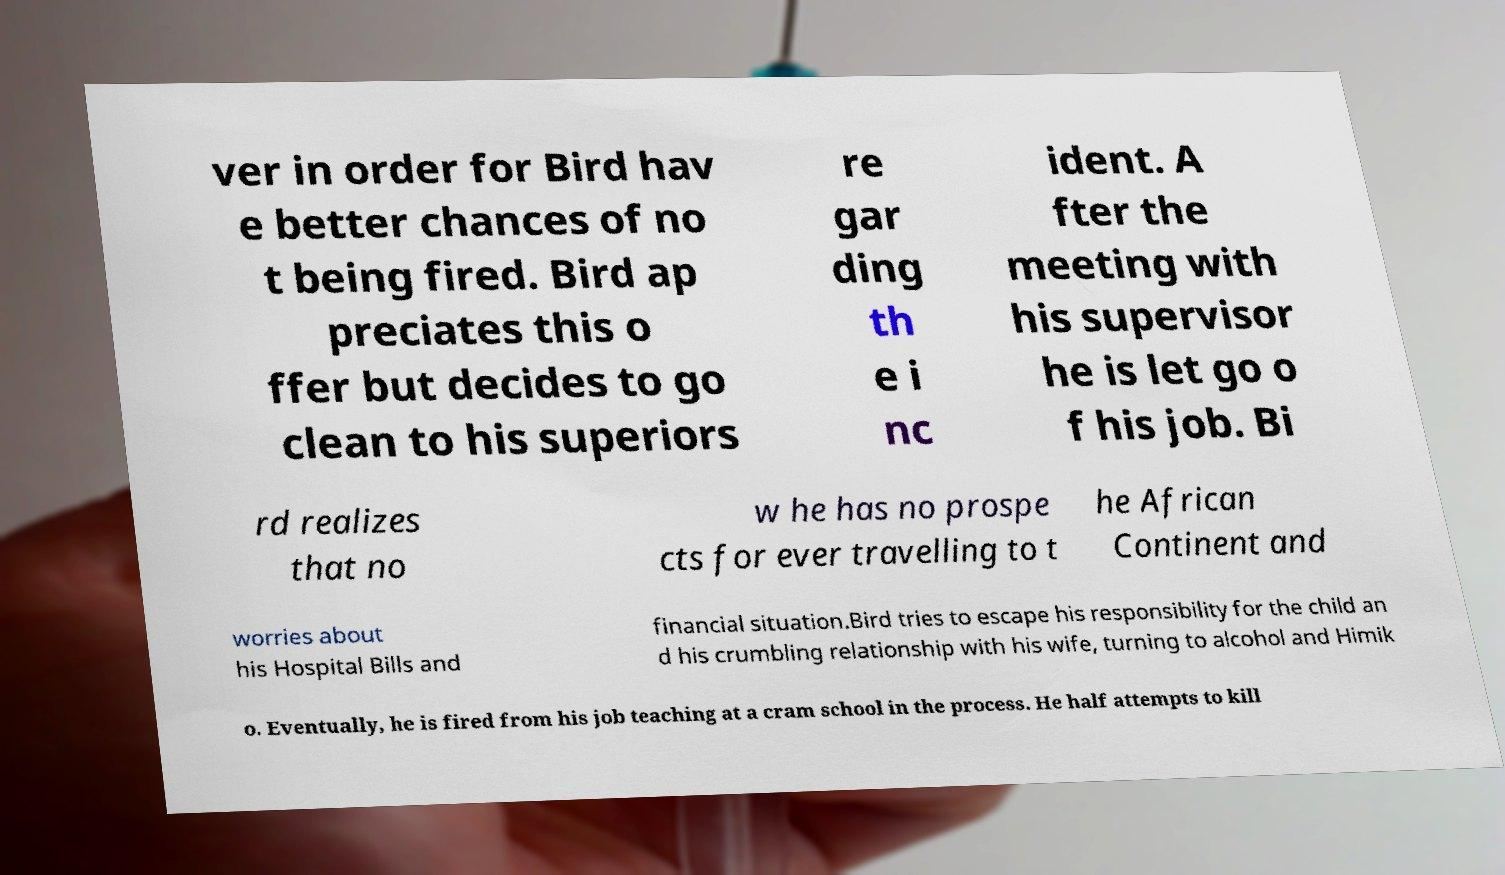Can you accurately transcribe the text from the provided image for me? ver in order for Bird hav e better chances of no t being fired. Bird ap preciates this o ffer but decides to go clean to his superiors re gar ding th e i nc ident. A fter the meeting with his supervisor he is let go o f his job. Bi rd realizes that no w he has no prospe cts for ever travelling to t he African Continent and worries about his Hospital Bills and financial situation.Bird tries to escape his responsibility for the child an d his crumbling relationship with his wife, turning to alcohol and Himik o. Eventually, he is fired from his job teaching at a cram school in the process. He half attempts to kill 